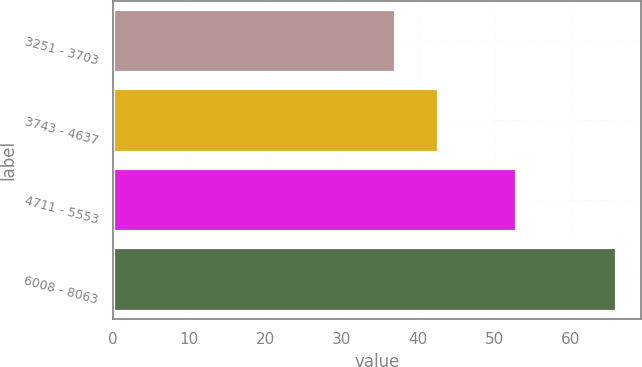<chart> <loc_0><loc_0><loc_500><loc_500><bar_chart><fcel>3251 - 3703<fcel>3743 - 4637<fcel>4711 - 5553<fcel>6008 - 8063<nl><fcel>37<fcel>42.67<fcel>52.84<fcel>65.99<nl></chart> 